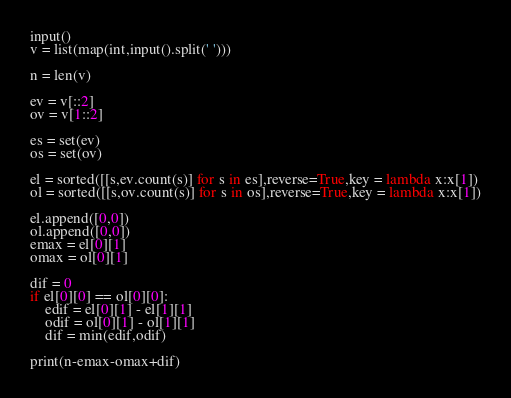Convert code to text. <code><loc_0><loc_0><loc_500><loc_500><_Python_>input()
v = list(map(int,input().split(' ')))

n = len(v)

ev = v[::2]
ov = v[1::2]

es = set(ev)
os = set(ov)

el = sorted([[s,ev.count(s)] for s in es],reverse=True,key = lambda x:x[1])
ol = sorted([[s,ov.count(s)] for s in os],reverse=True,key = lambda x:x[1])

el.append([0,0])
ol.append([0,0])
emax = el[0][1]
omax = ol[0][1]

dif = 0
if el[0][0] == ol[0][0]:
	edif = el[0][1] - el[1][1]
	odif = ol[0][1] - ol[1][1]
	dif = min(edif,odif)

print(n-emax-omax+dif)







</code> 